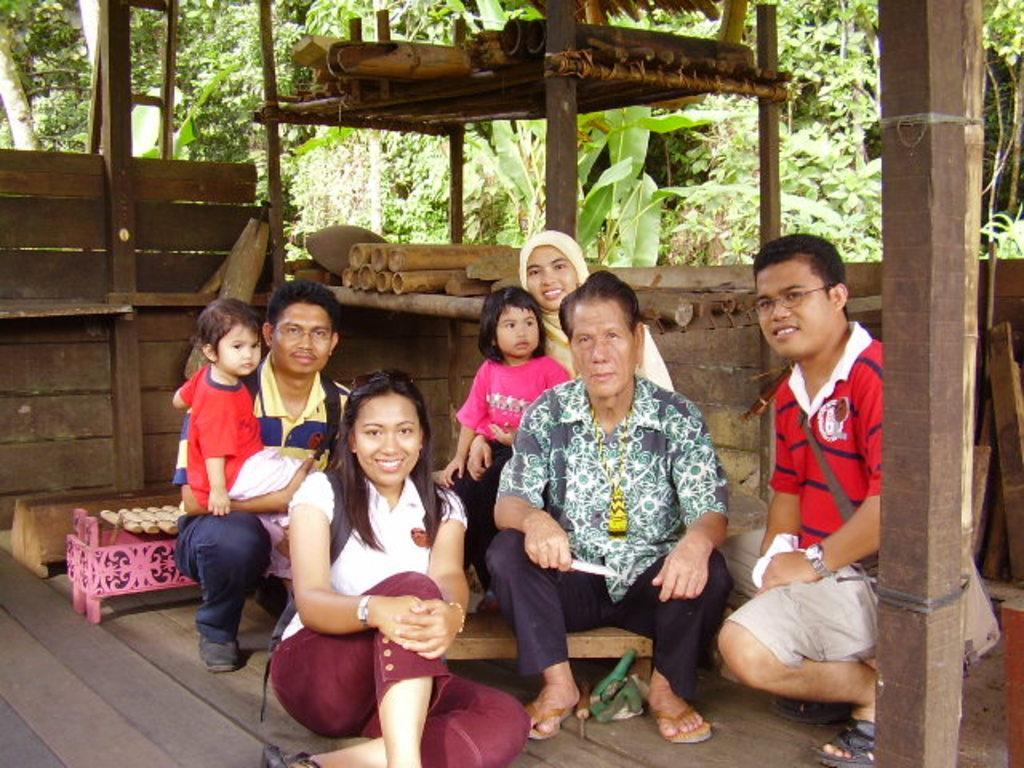Can you describe this image briefly? The man in the middle of the picture who is holding a knife in his hand is sitting on the stool. Behind him, we see a woman is sitting with her daughter. Beside him, we see a woman is sitting on the wooden floor. We see two men are in squad position. Behind him, we see stools. Behind them, we see the wooden wall and wooden sticks. On the right side, we see a wooden pole. There are trees in the background. 